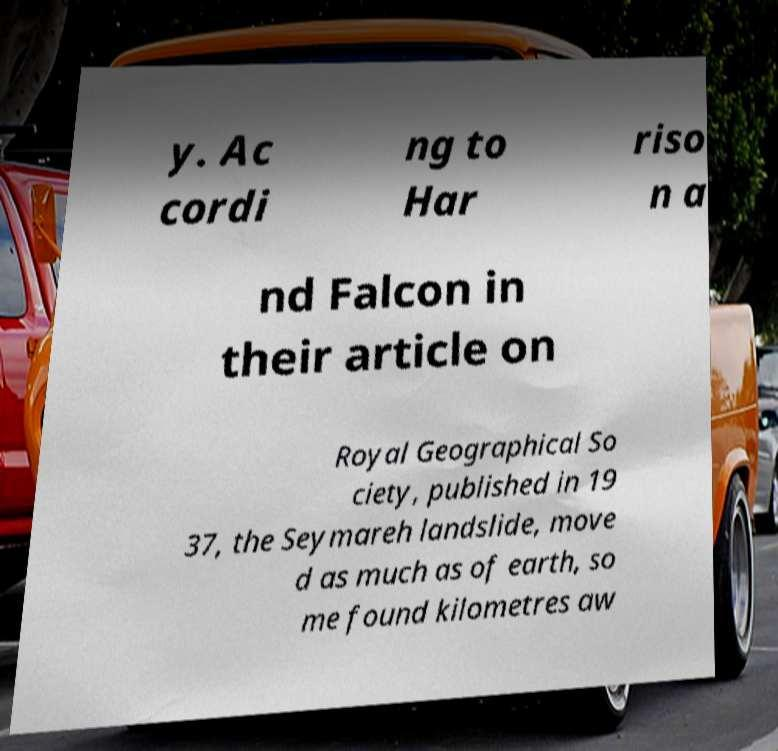For documentation purposes, I need the text within this image transcribed. Could you provide that? y. Ac cordi ng to Har riso n a nd Falcon in their article on Royal Geographical So ciety, published in 19 37, the Seymareh landslide, move d as much as of earth, so me found kilometres aw 